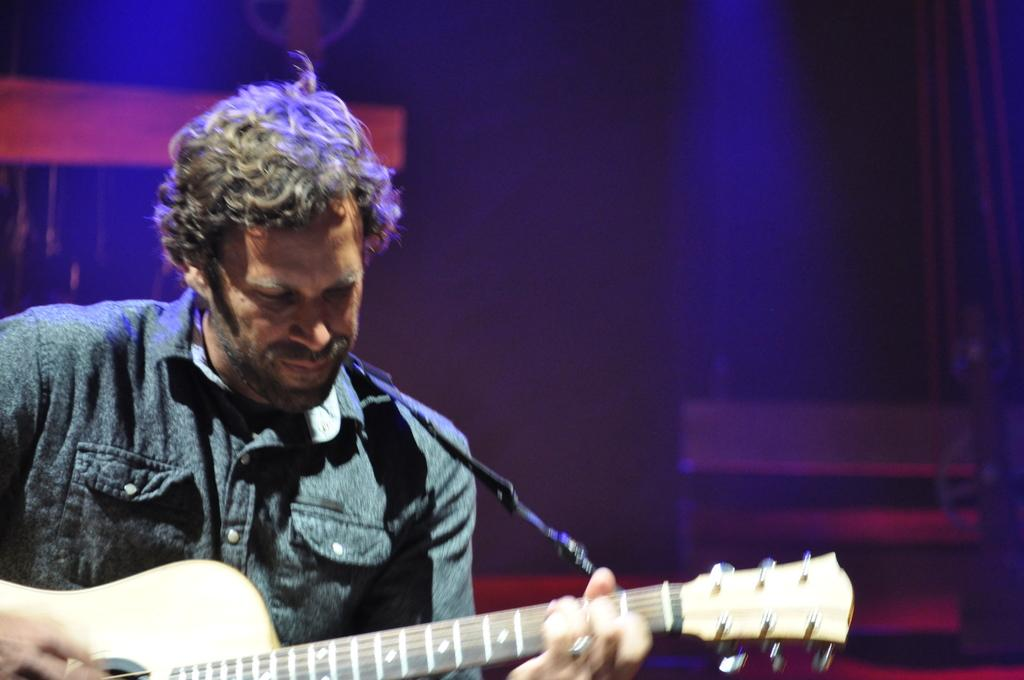Who or what is on the left side of the image? There is a person on the left side of the image. What is the person holding in the image? The person is holding a guitar in the image. What is the person doing with the guitar? The person is playing the guitar in the image. What type of throne can be seen in the image? There is no throne present in the image. What does the image smell like? The image does not have a smell, as it is a visual representation. 